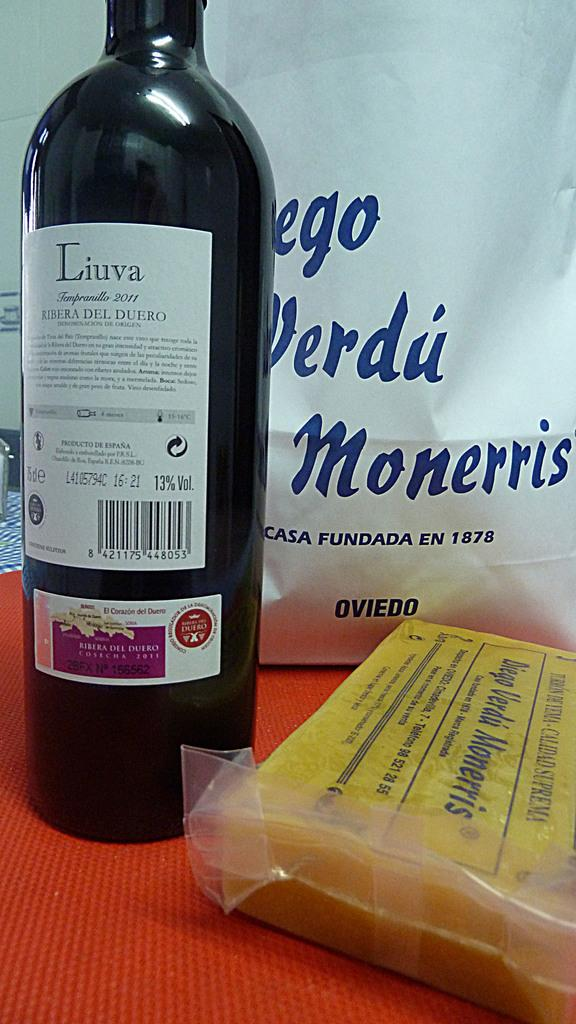<image>
Share a concise interpretation of the image provided. A tall bottle with the label Liuva written on it. 